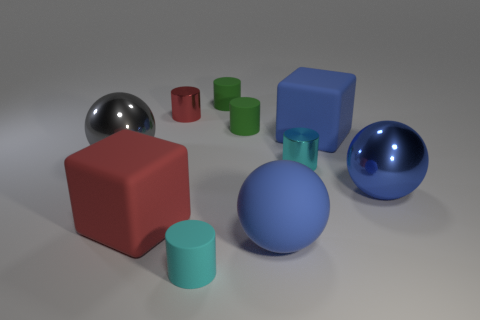Subtract all red cylinders. How many cylinders are left? 4 Subtract all tiny red metal cylinders. How many cylinders are left? 4 Subtract all gray cylinders. Subtract all purple cubes. How many cylinders are left? 5 Subtract all cubes. How many objects are left? 8 Subtract 0 purple cylinders. How many objects are left? 10 Subtract all red things. Subtract all small red objects. How many objects are left? 7 Add 3 matte blocks. How many matte blocks are left? 5 Add 7 big brown cylinders. How many big brown cylinders exist? 7 